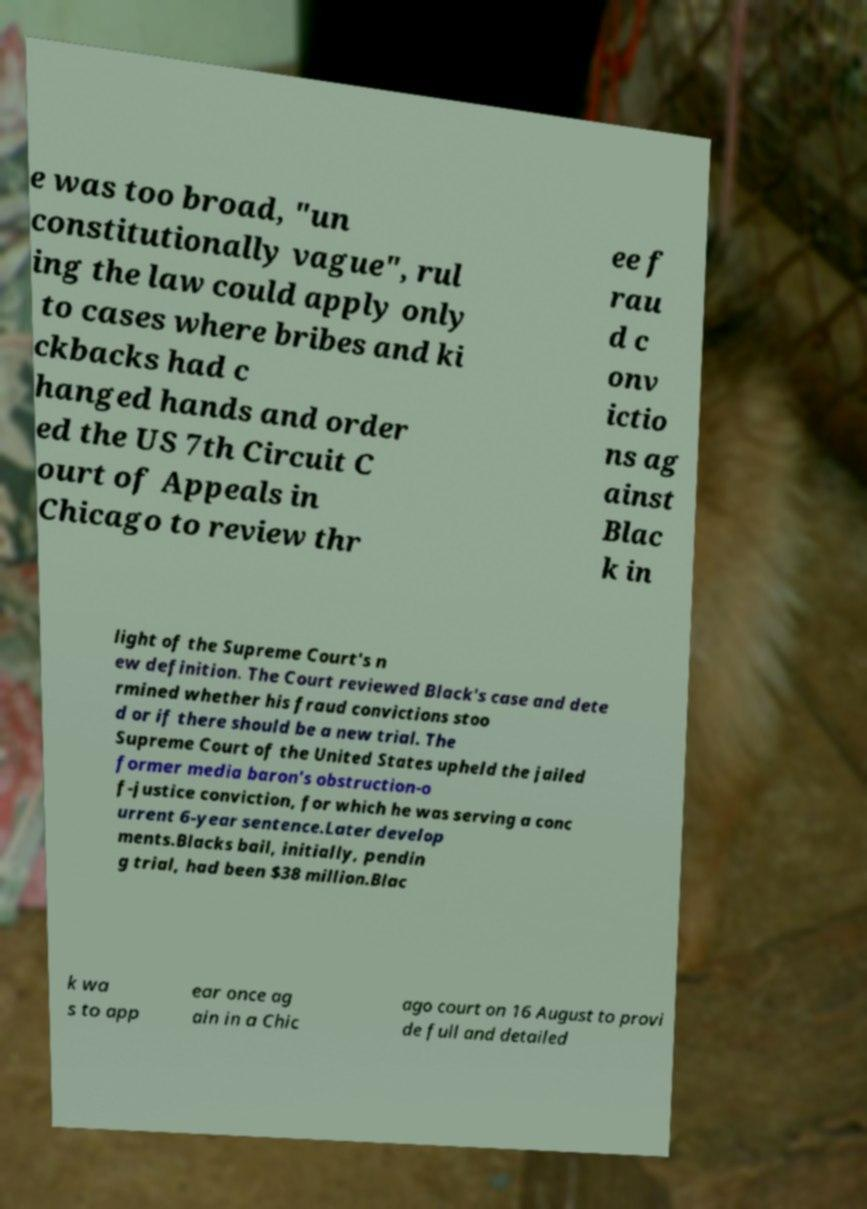Can you accurately transcribe the text from the provided image for me? e was too broad, "un constitutionally vague", rul ing the law could apply only to cases where bribes and ki ckbacks had c hanged hands and order ed the US 7th Circuit C ourt of Appeals in Chicago to review thr ee f rau d c onv ictio ns ag ainst Blac k in light of the Supreme Court's n ew definition. The Court reviewed Black's case and dete rmined whether his fraud convictions stoo d or if there should be a new trial. The Supreme Court of the United States upheld the jailed former media baron's obstruction-o f-justice conviction, for which he was serving a conc urrent 6-year sentence.Later develop ments.Blacks bail, initially, pendin g trial, had been $38 million.Blac k wa s to app ear once ag ain in a Chic ago court on 16 August to provi de full and detailed 